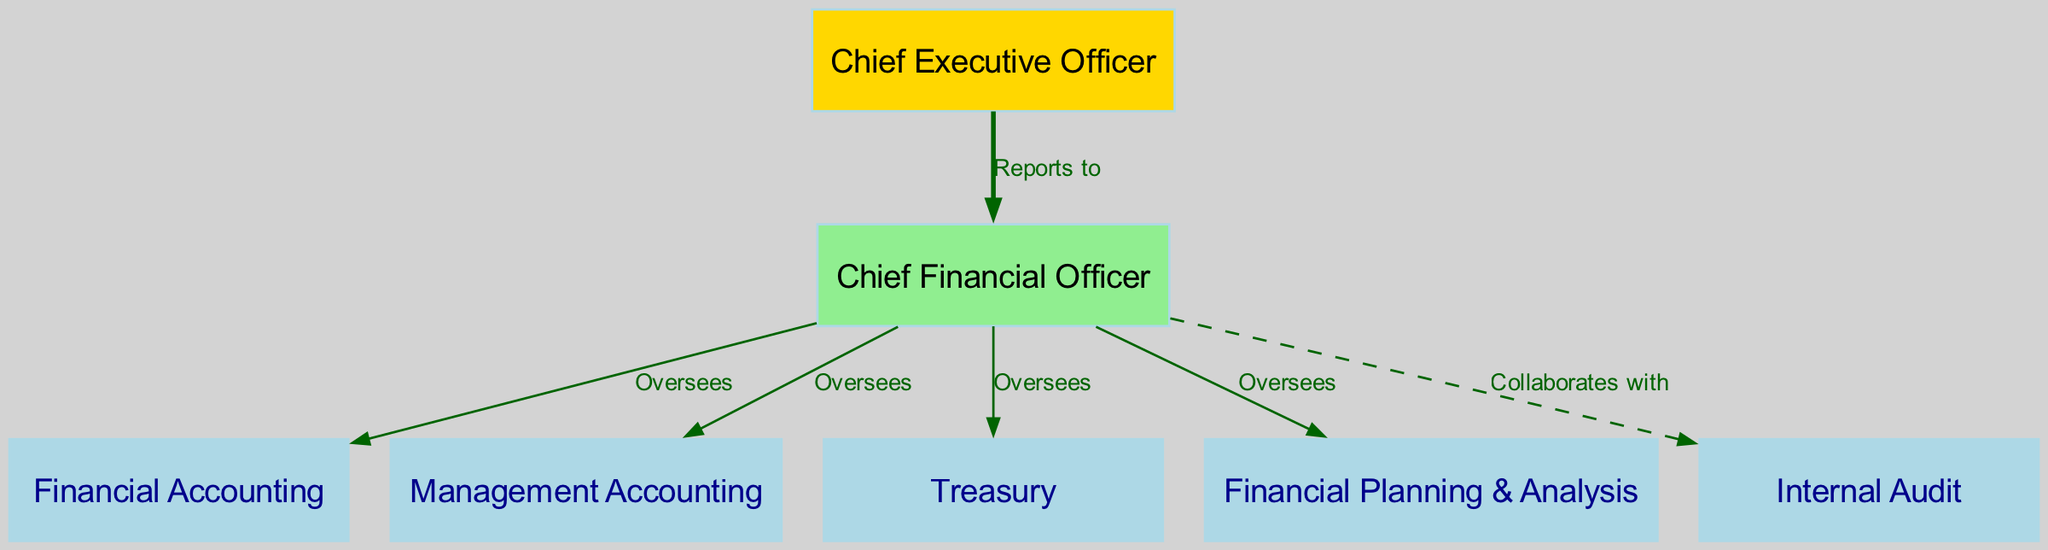What is the top-most position in the diagram? The diagram starts with the node labeled "Chief Executive Officer," indicating it is the highest position in the organizational structure.
Answer: Chief Executive Officer How many financial departments report to the Chief Financial Officer? The diagram shows four nodes labeled as financial departments (Financial Accounting, Management Accounting, Treasury, Financial Planning & Analysis) directly connected to the Chief Financial Officer.
Answer: Four Which department does the CFO collaborate with? The edge labeled "Collaborates with" connects the Chief Financial Officer to the Internal Audit department, indicating this is the department with which the CFO has a collaborative relationship.
Answer: Internal Audit What is the relationship between the CEO and the CFO? The edge labeled "Reports to" from the CEO to the CFO indicates that the CFO reports directly to the CEO, establishing a hierarchical relationship between these two positions.
Answer: Reports to How many edges are there in the diagram overall? The diagram includes a total of six edges that illustrate the relationships between the nodes, including one reporting relationship and five oversight or collaboration relationships.
Answer: Six Which department is specifically associated with financial accounting activities? In the diagram, the node labeled as "Financial Accounting" represents the specific department responsible for financial accounting activities within the company's financial structure.
Answer: Financial Accounting Which two departments does the CFO oversee that handle different aspects of accounting? The CFO oversees both the Financial Accounting and Management Accounting departments, which involve distinct but related areas of accounting practice.
Answer: Financial Accounting and Management Accounting What color is the node representing the Chief Financial Officer? In the diagram, the node representing the Chief Financial Officer is filled with a light green color, which distinguishes it from other nodes.
Answer: Light green Which department directly interacts with the CFO in a collaborative manner rather than an oversight manner? The Internal Audit department is indicated by a dashed edge labeled "Collaborates with," highlighting its direct interaction with the CFO in a non-hierarchical context.
Answer: Internal Audit 